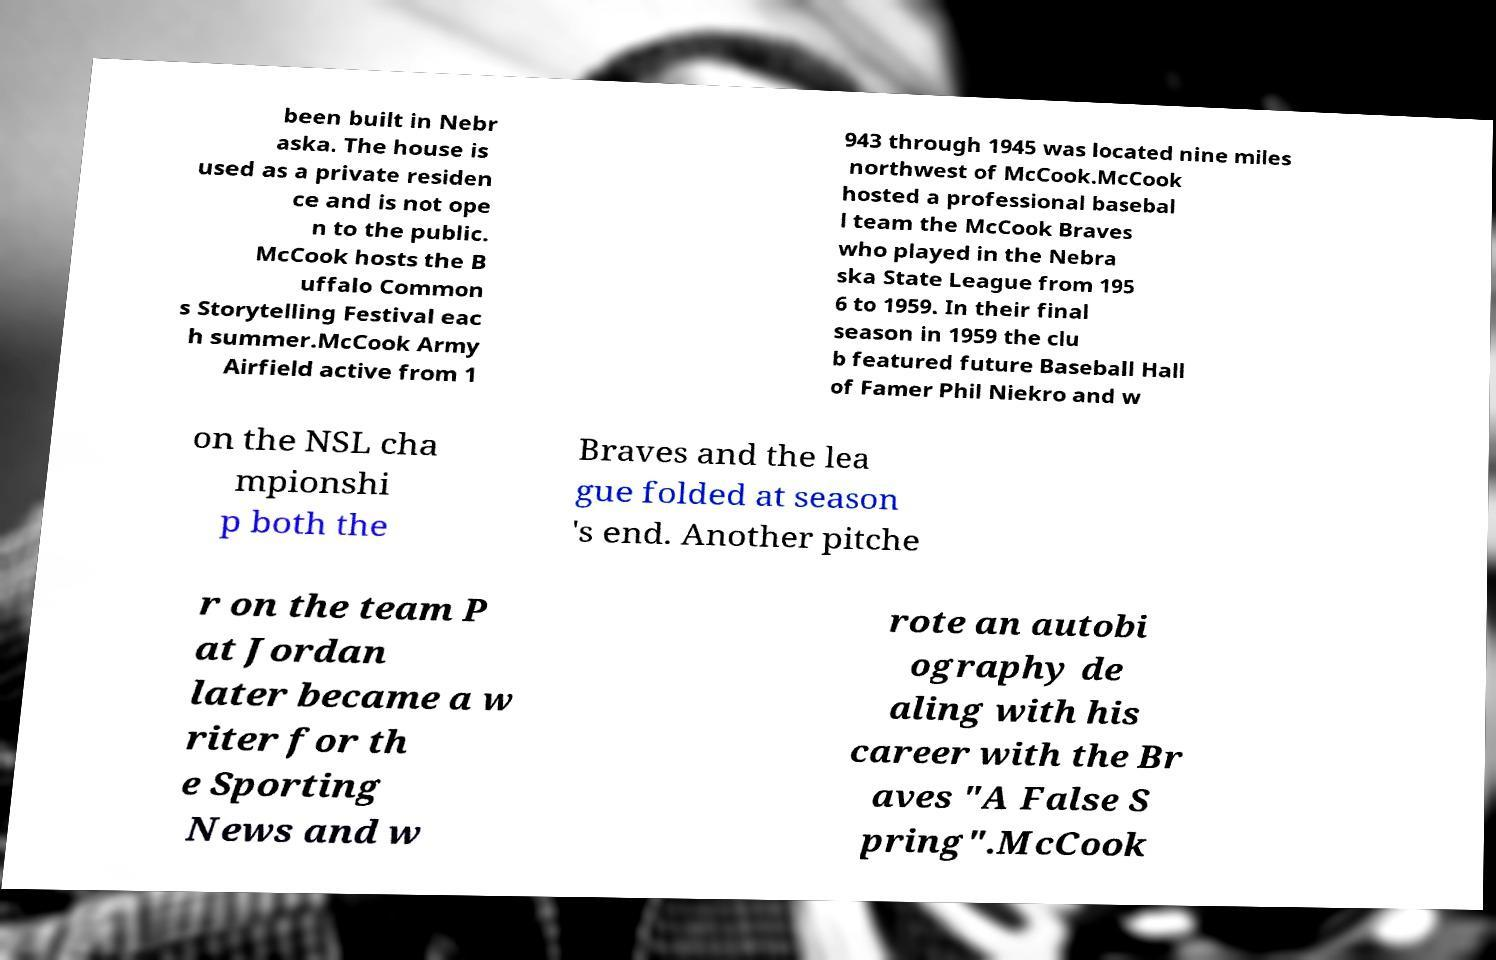What messages or text are displayed in this image? I need them in a readable, typed format. been built in Nebr aska. The house is used as a private residen ce and is not ope n to the public. McCook hosts the B uffalo Common s Storytelling Festival eac h summer.McCook Army Airfield active from 1 943 through 1945 was located nine miles northwest of McCook.McCook hosted a professional basebal l team the McCook Braves who played in the Nebra ska State League from 195 6 to 1959. In their final season in 1959 the clu b featured future Baseball Hall of Famer Phil Niekro and w on the NSL cha mpionshi p both the Braves and the lea gue folded at season 's end. Another pitche r on the team P at Jordan later became a w riter for th e Sporting News and w rote an autobi ography de aling with his career with the Br aves "A False S pring".McCook 